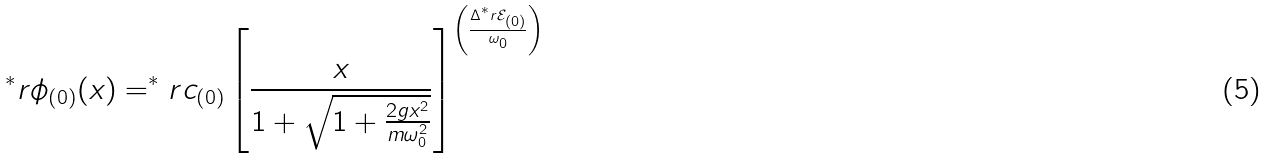Convert formula to latex. <formula><loc_0><loc_0><loc_500><loc_500>^ { * } r { \phi } _ { ( 0 ) } ( x ) = ^ { * } r { c } _ { ( 0 ) } \left [ \frac { x } { 1 + \sqrt { 1 + \frac { 2 g x ^ { 2 } } { m \omega _ { 0 } ^ { 2 } } } } \right ] ^ { \left ( \frac { \Delta ^ { * } r { \mathcal { E } } _ { ( 0 ) } } { \omega _ { 0 } } \right ) }</formula> 